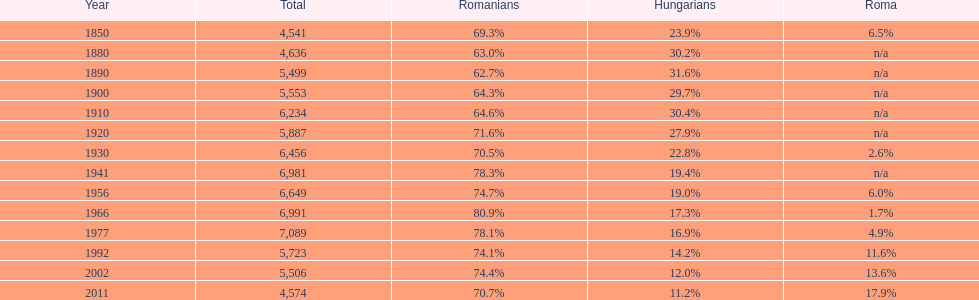What year had the highest total number? 1977. 